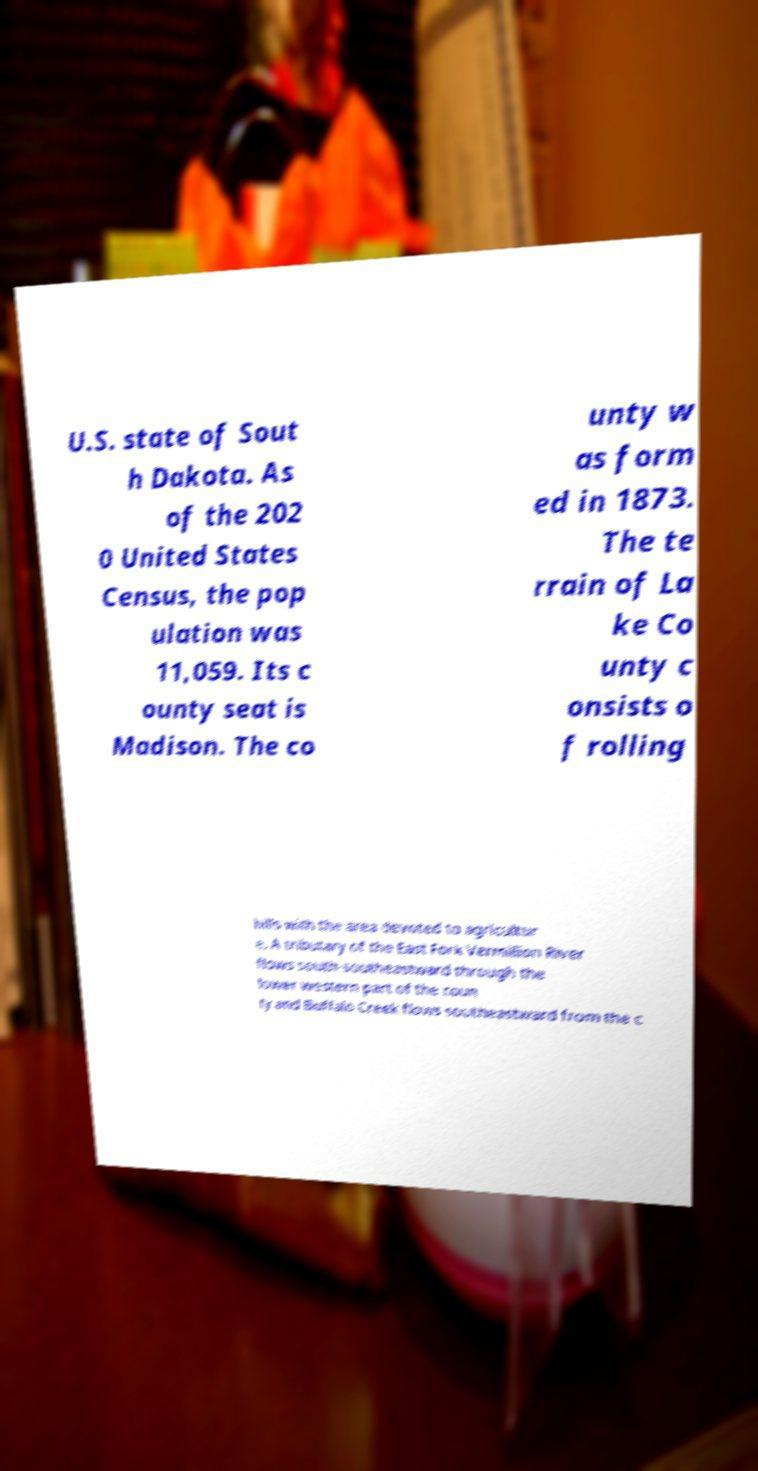Could you assist in decoding the text presented in this image and type it out clearly? U.S. state of Sout h Dakota. As of the 202 0 United States Census, the pop ulation was 11,059. Its c ounty seat is Madison. The co unty w as form ed in 1873. The te rrain of La ke Co unty c onsists o f rolling hills with the area devoted to agricultur e. A tributary of the East Fork Vermillion River flows south-southeastward through the lower western part of the coun ty and Buffalo Creek flows southeastward from the c 